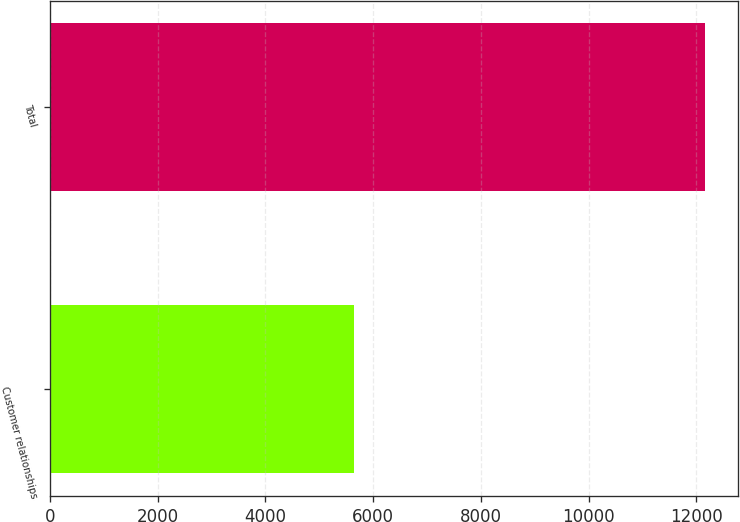Convert chart. <chart><loc_0><loc_0><loc_500><loc_500><bar_chart><fcel>Customer relationships<fcel>Total<nl><fcel>5647<fcel>12167<nl></chart> 